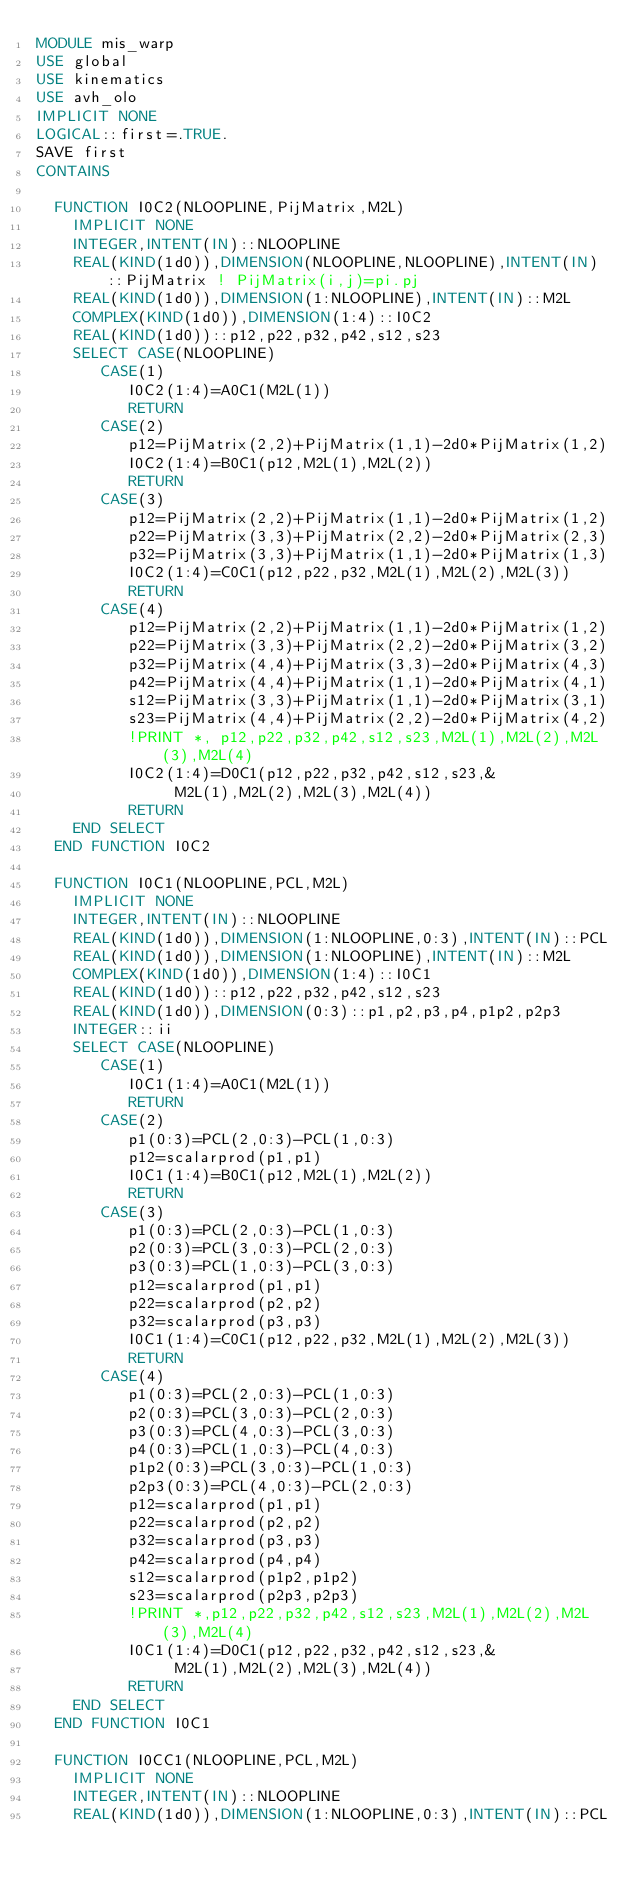Convert code to text. <code><loc_0><loc_0><loc_500><loc_500><_FORTRAN_>MODULE mis_warp
USE global
USE kinematics
USE avh_olo
IMPLICIT NONE
LOGICAL::first=.TRUE.
SAVE first
CONTAINS

  FUNCTION I0C2(NLOOPLINE,PijMatrix,M2L)
    IMPLICIT NONE
    INTEGER,INTENT(IN)::NLOOPLINE
    REAL(KIND(1d0)),DIMENSION(NLOOPLINE,NLOOPLINE),INTENT(IN)::PijMatrix ! PijMatrix(i,j)=pi.pj
    REAL(KIND(1d0)),DIMENSION(1:NLOOPLINE),INTENT(IN)::M2L
    COMPLEX(KIND(1d0)),DIMENSION(1:4)::I0C2
    REAL(KIND(1d0))::p12,p22,p32,p42,s12,s23
    SELECT CASE(NLOOPLINE)
       CASE(1)
          I0C2(1:4)=A0C1(M2L(1))
          RETURN
       CASE(2)
          p12=PijMatrix(2,2)+PijMatrix(1,1)-2d0*PijMatrix(1,2)
          I0C2(1:4)=B0C1(p12,M2L(1),M2L(2))
          RETURN
       CASE(3)
          p12=PijMatrix(2,2)+PijMatrix(1,1)-2d0*PijMatrix(1,2)
          p22=PijMatrix(3,3)+PijMatrix(2,2)-2d0*PijMatrix(2,3)
          p32=PijMatrix(3,3)+PijMatrix(1,1)-2d0*PijMatrix(1,3)
          I0C2(1:4)=C0C1(p12,p22,p32,M2L(1),M2L(2),M2L(3))
          RETURN
       CASE(4)          
          p12=PijMatrix(2,2)+PijMatrix(1,1)-2d0*PijMatrix(1,2)
          p22=PijMatrix(3,3)+PijMatrix(2,2)-2d0*PijMatrix(3,2)
          p32=PijMatrix(4,4)+PijMatrix(3,3)-2d0*PijMatrix(4,3)
          p42=PijMatrix(4,4)+PijMatrix(1,1)-2d0*PijMatrix(4,1)
          s12=PijMatrix(3,3)+PijMatrix(1,1)-2d0*PijMatrix(3,1)
          s23=PijMatrix(4,4)+PijMatrix(2,2)-2d0*PijMatrix(4,2)
          !PRINT *, p12,p22,p32,p42,s12,s23,M2L(1),M2L(2),M2L(3),M2L(4)
          I0C2(1:4)=D0C1(p12,p22,p32,p42,s12,s23,&
               M2L(1),M2L(2),M2L(3),M2L(4))
          RETURN
    END SELECT
  END FUNCTION I0C2

  FUNCTION I0C1(NLOOPLINE,PCL,M2L)
    IMPLICIT NONE
    INTEGER,INTENT(IN)::NLOOPLINE
    REAL(KIND(1d0)),DIMENSION(1:NLOOPLINE,0:3),INTENT(IN)::PCL
    REAL(KIND(1d0)),DIMENSION(1:NLOOPLINE),INTENT(IN)::M2L
    COMPLEX(KIND(1d0)),DIMENSION(1:4)::I0C1
    REAL(KIND(1d0))::p12,p22,p32,p42,s12,s23
    REAL(KIND(1d0)),DIMENSION(0:3)::p1,p2,p3,p4,p1p2,p2p3
    INTEGER::ii
    SELECT CASE(NLOOPLINE)
       CASE(1)
          I0C1(1:4)=A0C1(M2L(1))
          RETURN
       CASE(2)
          p1(0:3)=PCL(2,0:3)-PCL(1,0:3)
          p12=scalarprod(p1,p1)
          I0C1(1:4)=B0C1(p12,M2L(1),M2L(2))
          RETURN
       CASE(3)
          p1(0:3)=PCL(2,0:3)-PCL(1,0:3)
          p2(0:3)=PCL(3,0:3)-PCL(2,0:3)
          p3(0:3)=PCL(1,0:3)-PCL(3,0:3)
          p12=scalarprod(p1,p1)
          p22=scalarprod(p2,p2)
          p32=scalarprod(p3,p3)
          I0C1(1:4)=C0C1(p12,p22,p32,M2L(1),M2L(2),M2L(3))
          RETURN
       CASE(4)
          p1(0:3)=PCL(2,0:3)-PCL(1,0:3)
          p2(0:3)=PCL(3,0:3)-PCL(2,0:3)
          p3(0:3)=PCL(4,0:3)-PCL(3,0:3)
          p4(0:3)=PCL(1,0:3)-PCL(4,0:3)
          p1p2(0:3)=PCL(3,0:3)-PCL(1,0:3)
          p2p3(0:3)=PCL(4,0:3)-PCL(2,0:3)
          p12=scalarprod(p1,p1)
          p22=scalarprod(p2,p2)
          p32=scalarprod(p3,p3)
          p42=scalarprod(p4,p4)
          s12=scalarprod(p1p2,p1p2)
          s23=scalarprod(p2p3,p2p3)
          !PRINT *,p12,p22,p32,p42,s12,s23,M2L(1),M2L(2),M2L(3),M2L(4) 
          I0C1(1:4)=D0C1(p12,p22,p32,p42,s12,s23,&
               M2L(1),M2L(2),M2L(3),M2L(4))
          RETURN
    END SELECT
  END FUNCTION I0C1

  FUNCTION I0CC1(NLOOPLINE,PCL,M2L)
    IMPLICIT NONE
    INTEGER,INTENT(IN)::NLOOPLINE
    REAL(KIND(1d0)),DIMENSION(1:NLOOPLINE,0:3),INTENT(IN)::PCL</code> 